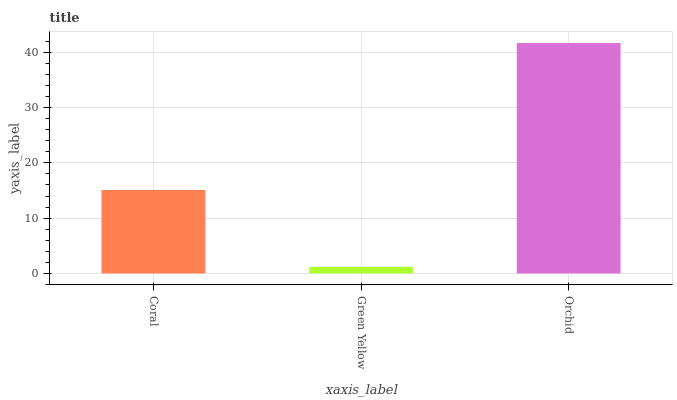Is Green Yellow the minimum?
Answer yes or no. Yes. Is Orchid the maximum?
Answer yes or no. Yes. Is Orchid the minimum?
Answer yes or no. No. Is Green Yellow the maximum?
Answer yes or no. No. Is Orchid greater than Green Yellow?
Answer yes or no. Yes. Is Green Yellow less than Orchid?
Answer yes or no. Yes. Is Green Yellow greater than Orchid?
Answer yes or no. No. Is Orchid less than Green Yellow?
Answer yes or no. No. Is Coral the high median?
Answer yes or no. Yes. Is Coral the low median?
Answer yes or no. Yes. Is Orchid the high median?
Answer yes or no. No. Is Orchid the low median?
Answer yes or no. No. 